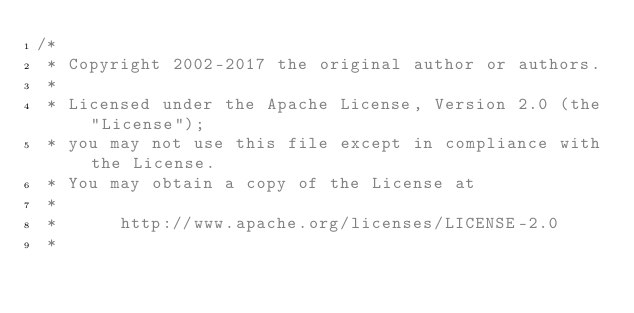Convert code to text. <code><loc_0><loc_0><loc_500><loc_500><_Kotlin_>/*
 * Copyright 2002-2017 the original author or authors.
 *
 * Licensed under the Apache License, Version 2.0 (the "License");
 * you may not use this file except in compliance with the License.
 * You may obtain a copy of the License at
 *
 *      http://www.apache.org/licenses/LICENSE-2.0
 *</code> 